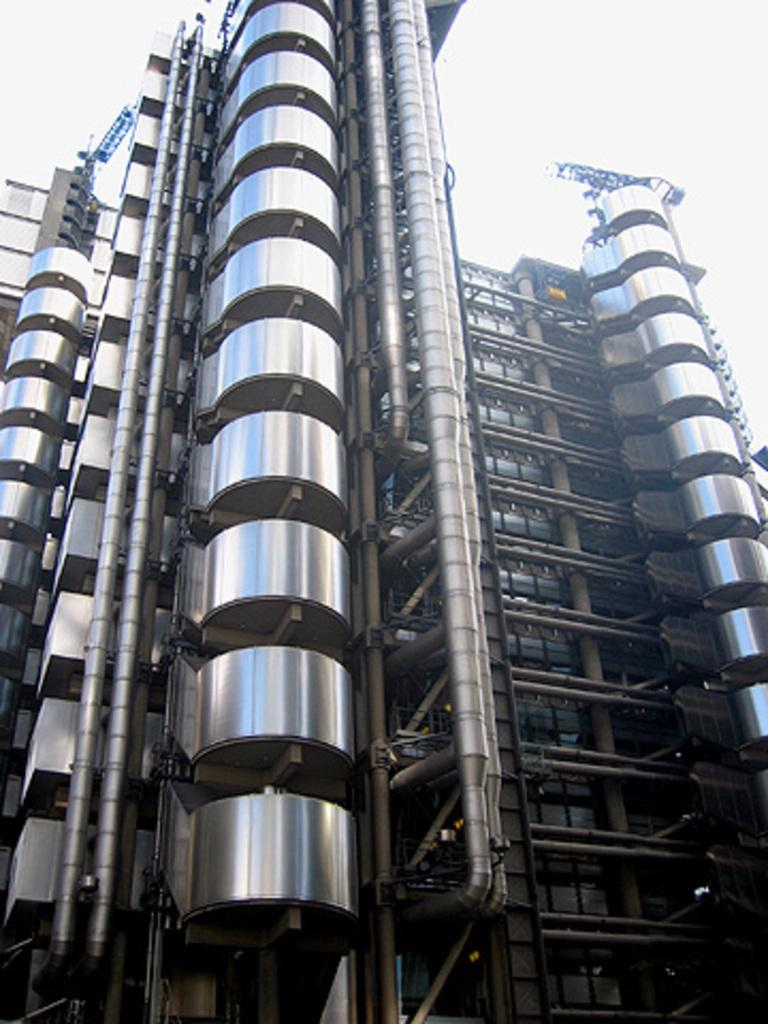What type of structure can be seen in the image? There is a building in the image. What part of the natural environment is visible in the image? The sky is visible in the image. What type of wax can be seen melting on the building in the image? There is no wax present in the image, and therefore no such activity can be observed. 